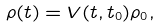Convert formula to latex. <formula><loc_0><loc_0><loc_500><loc_500>\rho ( t ) = V ( t , t _ { 0 } ) \rho _ { 0 } ,</formula> 